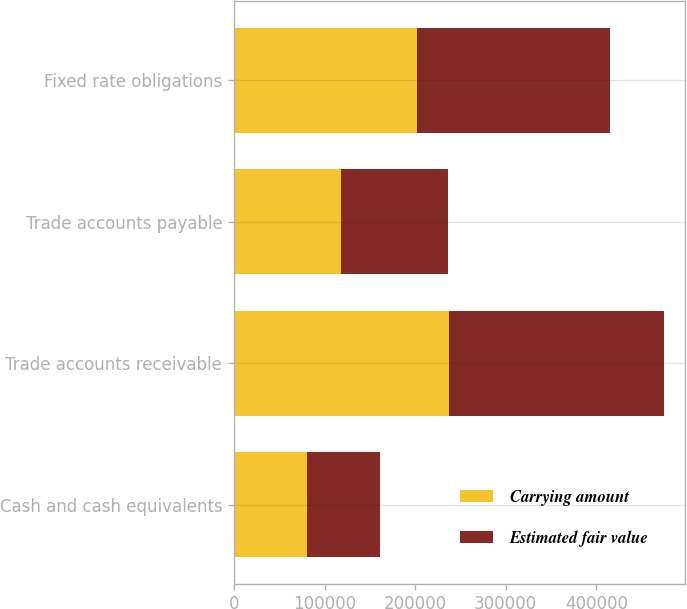Convert chart. <chart><loc_0><loc_0><loc_500><loc_500><stacked_bar_chart><ecel><fcel>Cash and cash equivalents<fcel>Trade accounts receivable<fcel>Trade accounts payable<fcel>Fixed rate obligations<nl><fcel>Carrying amount<fcel>80628<fcel>237156<fcel>117931<fcel>202010<nl><fcel>Estimated fair value<fcel>80628<fcel>237156<fcel>117931<fcel>213397<nl></chart> 